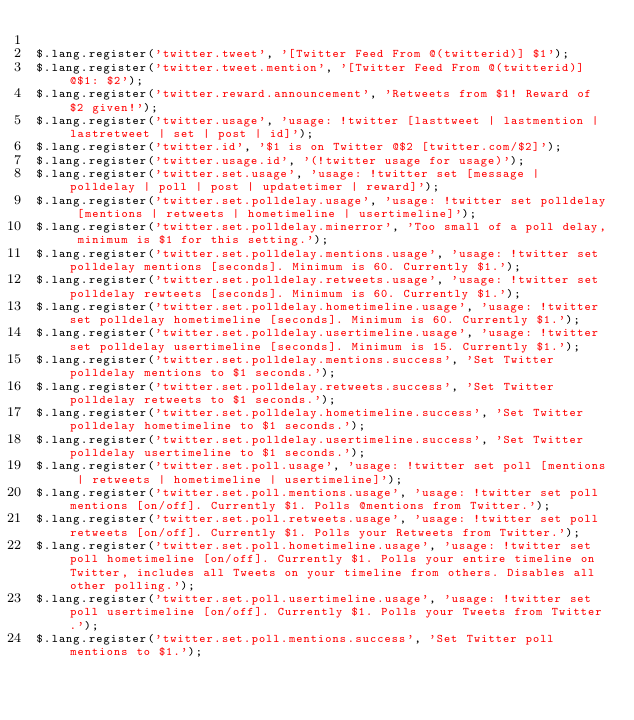Convert code to text. <code><loc_0><loc_0><loc_500><loc_500><_JavaScript_>
$.lang.register('twitter.tweet', '[Twitter Feed From @(twitterid)] $1');
$.lang.register('twitter.tweet.mention', '[Twitter Feed From @(twitterid)] @$1: $2');
$.lang.register('twitter.reward.announcement', 'Retweets from $1! Reward of $2 given!');
$.lang.register('twitter.usage', 'usage: !twitter [lasttweet | lastmention | lastretweet | set | post | id]');
$.lang.register('twitter.id', '$1 is on Twitter @$2 [twitter.com/$2]');
$.lang.register('twitter.usage.id', '(!twitter usage for usage)');
$.lang.register('twitter.set.usage', 'usage: !twitter set [message | polldelay | poll | post | updatetimer | reward]');
$.lang.register('twitter.set.polldelay.usage', 'usage: !twitter set polldelay [mentions | retweets | hometimeline | usertimeline]');
$.lang.register('twitter.set.polldelay.minerror', 'Too small of a poll delay, minimum is $1 for this setting.');
$.lang.register('twitter.set.polldelay.mentions.usage', 'usage: !twitter set polldelay mentions [seconds]. Minimum is 60. Currently $1.');
$.lang.register('twitter.set.polldelay.retweets.usage', 'usage: !twitter set polldelay rewteets [seconds]. Minimum is 60. Currently $1.');
$.lang.register('twitter.set.polldelay.hometimeline.usage', 'usage: !twitter set polldelay hometimeline [seconds]. Minimum is 60. Currently $1.');
$.lang.register('twitter.set.polldelay.usertimeline.usage', 'usage: !twitter set polldelay usertimeline [seconds]. Minimum is 15. Currently $1.');
$.lang.register('twitter.set.polldelay.mentions.success', 'Set Twitter polldelay mentions to $1 seconds.');
$.lang.register('twitter.set.polldelay.retweets.success', 'Set Twitter polldelay retweets to $1 seconds.');
$.lang.register('twitter.set.polldelay.hometimeline.success', 'Set Twitter polldelay hometimeline to $1 seconds.');
$.lang.register('twitter.set.polldelay.usertimeline.success', 'Set Twitter polldelay usertimeline to $1 seconds.');
$.lang.register('twitter.set.poll.usage', 'usage: !twitter set poll [mentions | retweets | hometimeline | usertimeline]');
$.lang.register('twitter.set.poll.mentions.usage', 'usage: !twitter set poll mentions [on/off]. Currently $1. Polls @mentions from Twitter.');
$.lang.register('twitter.set.poll.retweets.usage', 'usage: !twitter set poll retweets [on/off]. Currently $1. Polls your Retweets from Twitter.');
$.lang.register('twitter.set.poll.hometimeline.usage', 'usage: !twitter set poll hometimeline [on/off]. Currently $1. Polls your entire timeline on Twitter, includes all Tweets on your timeline from others. Disables all other polling.');
$.lang.register('twitter.set.poll.usertimeline.usage', 'usage: !twitter set poll usertimeline [on/off]. Currently $1. Polls your Tweets from Twitter.');
$.lang.register('twitter.set.poll.mentions.success', 'Set Twitter poll mentions to $1.');</code> 